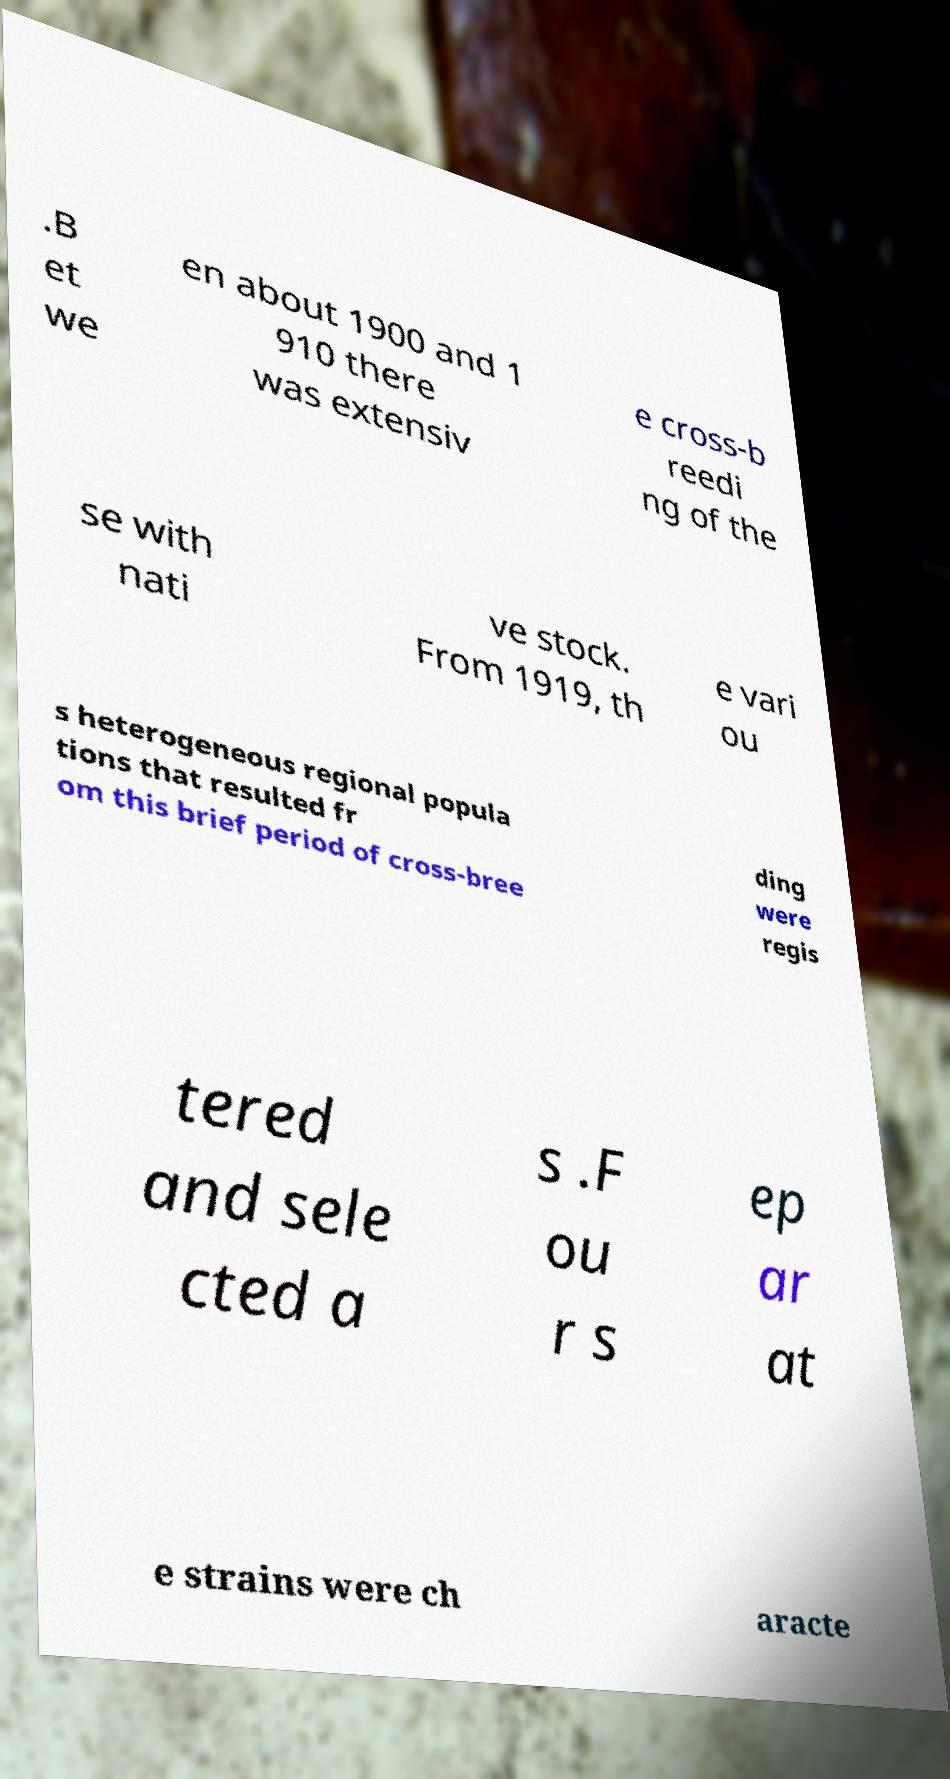There's text embedded in this image that I need extracted. Can you transcribe it verbatim? .B et we en about 1900 and 1 910 there was extensiv e cross-b reedi ng of the se with nati ve stock. From 1919, th e vari ou s heterogeneous regional popula tions that resulted fr om this brief period of cross-bree ding were regis tered and sele cted a s .F ou r s ep ar at e strains were ch aracte 